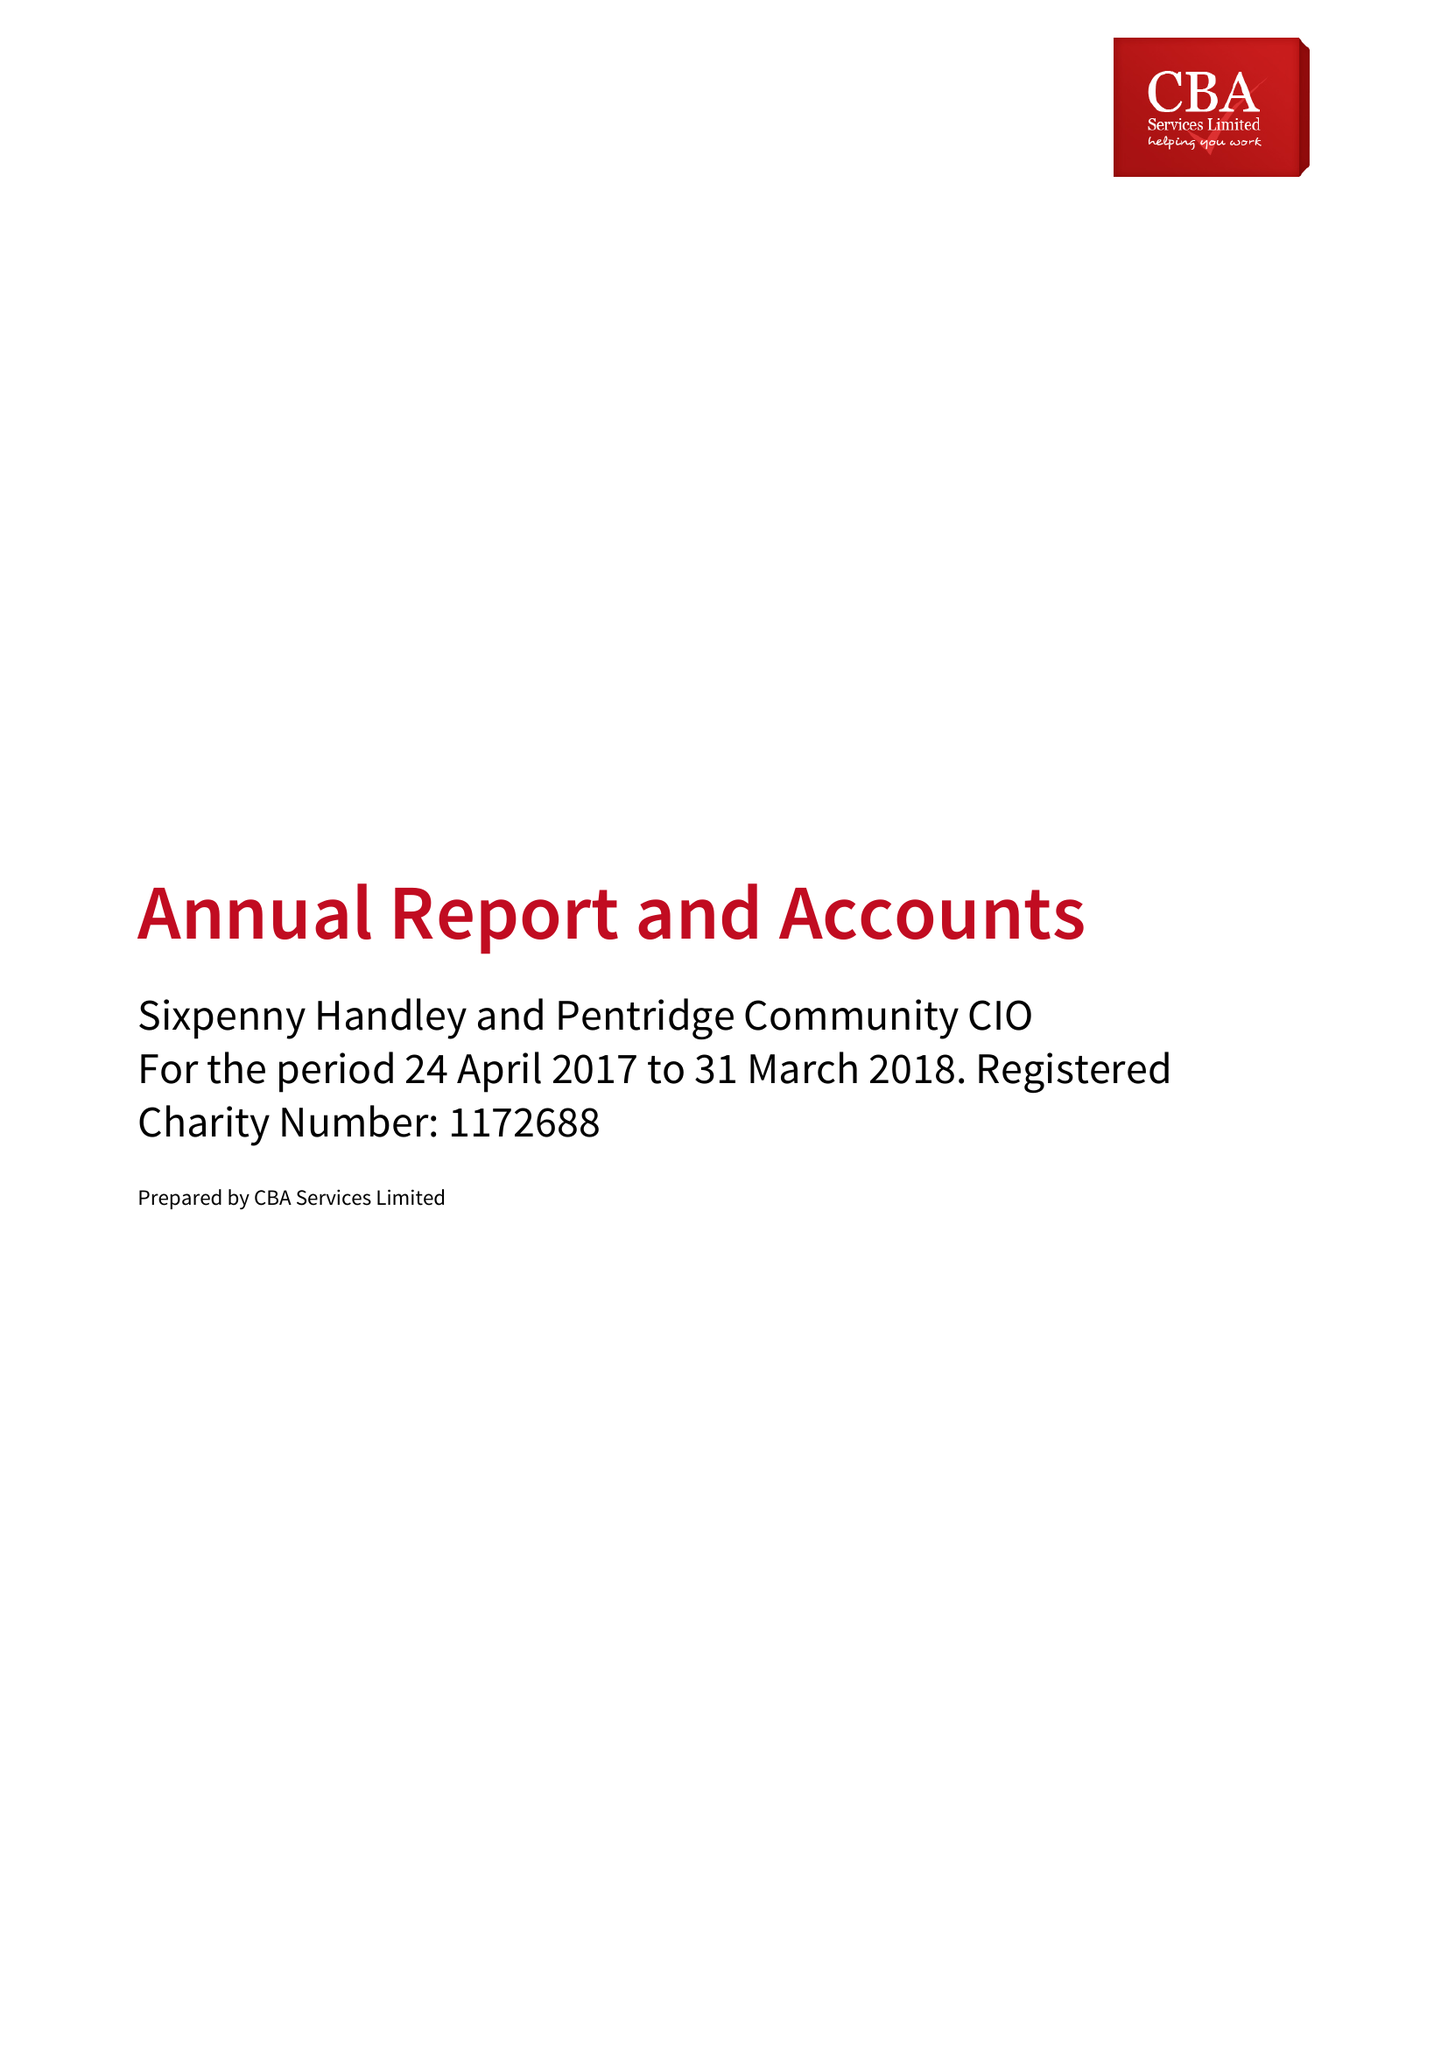What is the value for the address__post_town?
Answer the question using a single word or phrase. SALISBURY 